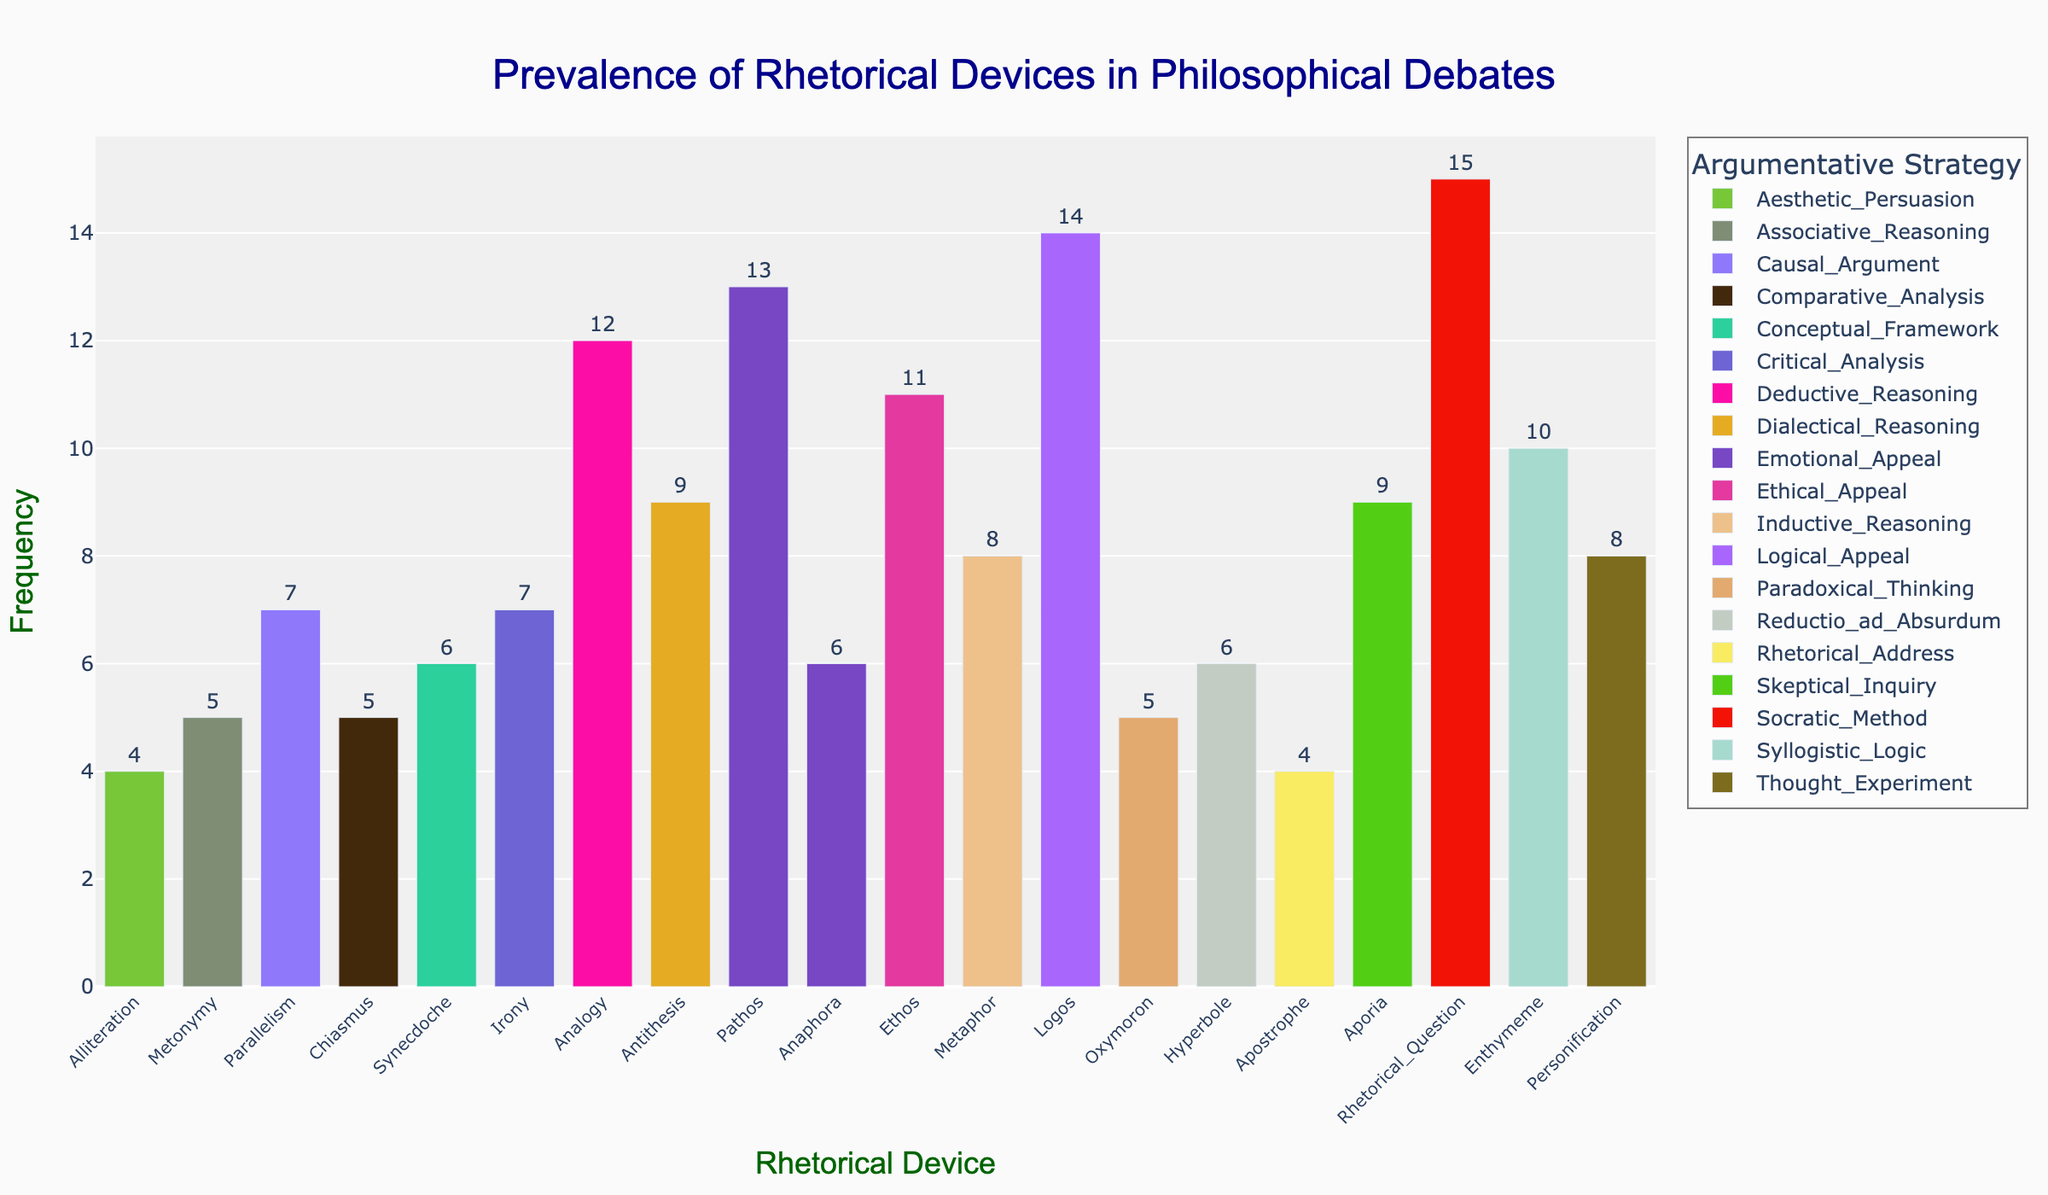Which rhetorical device has the highest frequency? The bar with the tallest height represents the rhetorical device with the highest frequency. According to the plot, the device "Rhetorical Question" has the tallest bar among all devices.
Answer: Rhetorical Question What is the title of the plot? The title is usually displayed at the top of the plot. In this figure, the title is "Prevalence of Rhetorical Devices in Philosophical Debates."
Answer: Prevalence of Rhetorical Devices in Philosophical Debates How many rhetorical devices are associated with Emotional Appeal? Find the bars in the plot that are labeled with the argumentative strategy "Emotional Appeal." There are two such bars: "Anaphora" and "Pathos."
Answer: 2 Which argumentative strategy has the most devices with a frequency greater than 10? Look at each argumentative strategy and count the number of devices with bars taller than the height corresponding to a frequency of 10. "Ethical Appeal" (Ethos) has one, "Emotional Appeal" (Pathos) has one, "Logical Appeal" (Logos) has one, and "Socratic Method" (Rhetorical Question) has one.
Answer: Ethical Appeal, Emotional Appeal, Logical Appeal, and Socratic Method (all equal) Sort the devices under Deductive Reasoning by frequency from highest to lowest. Find the bars corresponding to Deductive Reasoning and sort them based on the height of the bars from highest to lowest. Deductive Reasoning has one device: "Analogy."
Answer: Analogy Which argumentative strategy appears the least frequently across all devices? Count the number of bars for each argumentative strategy and identify the one with the fewest bars. "Aesthetic Persuasion" and "Rhetorical Address" have only one bar each.
Answer: Aesthetic Persuasion, Rhetorical Address Is the frequency of devices used in Logical Appeal higher or lower than that in Emotional Appeal? Compare the heights of bars for the devices under "Logical Appeal" (Logos) and "Emotional Appeal" (Anaphora and Pathos). Logical Appeal has a frequency of 14, while Emotional Appeal has a total frequency of 6 + 13 = 19.
Answer: Lower Calculate the average frequency of devices under Inductive Reasoning. Find the bars for Inductive Reasoning and sum their frequencies, then divide by the number of devices. Inductive Reasoning includes "Metaphor" with a frequency of 8. The average is 8/1.
Answer: 8 Which rhetorical device has the lowest frequency? Identify the bar with the shortest height in the plot. "Alliteration" and "Apostrophe" both have the shortest bars with a frequency of 4.
Answer: Alliteration, Apostrophe How much higher is the frequency of Logos compared to Metonymy? Find the height of the bar for Logos (14) and Metonymy (5), then subtract the latter from the former. 14 - 5 = 9.
Answer: 9 